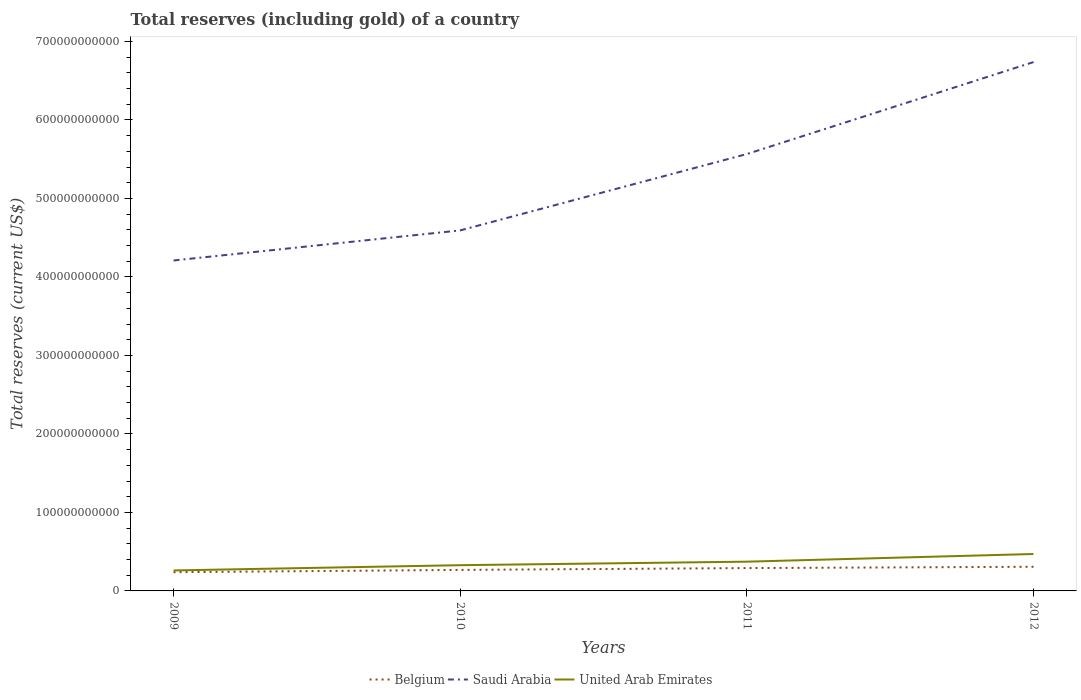Is the number of lines equal to the number of legend labels?
Offer a very short reply. Yes. Across all years, what is the maximum total reserves (including gold) in United Arab Emirates?
Provide a short and direct response. 2.61e+1. What is the total total reserves (including gold) in Belgium in the graph?
Provide a short and direct response. -3.99e+09. What is the difference between the highest and the second highest total reserves (including gold) in United Arab Emirates?
Ensure brevity in your answer.  2.09e+1. What is the difference between the highest and the lowest total reserves (including gold) in Saudi Arabia?
Your response must be concise. 2. Is the total reserves (including gold) in Saudi Arabia strictly greater than the total reserves (including gold) in United Arab Emirates over the years?
Offer a very short reply. No. How many years are there in the graph?
Ensure brevity in your answer.  4. What is the difference between two consecutive major ticks on the Y-axis?
Give a very brief answer. 1.00e+11. Are the values on the major ticks of Y-axis written in scientific E-notation?
Your answer should be compact. No. Where does the legend appear in the graph?
Provide a short and direct response. Bottom center. How many legend labels are there?
Offer a very short reply. 3. What is the title of the graph?
Provide a succinct answer. Total reserves (including gold) of a country. What is the label or title of the Y-axis?
Give a very brief answer. Total reserves (current US$). What is the Total reserves (current US$) of Belgium in 2009?
Provide a succinct answer. 2.39e+1. What is the Total reserves (current US$) in Saudi Arabia in 2009?
Ensure brevity in your answer.  4.21e+11. What is the Total reserves (current US$) in United Arab Emirates in 2009?
Your response must be concise. 2.61e+1. What is the Total reserves (current US$) of Belgium in 2010?
Keep it short and to the point. 2.68e+1. What is the Total reserves (current US$) in Saudi Arabia in 2010?
Offer a terse response. 4.59e+11. What is the Total reserves (current US$) of United Arab Emirates in 2010?
Provide a short and direct response. 3.28e+1. What is the Total reserves (current US$) in Belgium in 2011?
Provide a short and direct response. 2.91e+1. What is the Total reserves (current US$) in Saudi Arabia in 2011?
Provide a short and direct response. 5.57e+11. What is the Total reserves (current US$) of United Arab Emirates in 2011?
Your answer should be very brief. 3.73e+1. What is the Total reserves (current US$) in Belgium in 2012?
Provide a succinct answer. 3.08e+1. What is the Total reserves (current US$) in Saudi Arabia in 2012?
Your answer should be very brief. 6.74e+11. What is the Total reserves (current US$) in United Arab Emirates in 2012?
Your answer should be compact. 4.70e+1. Across all years, what is the maximum Total reserves (current US$) of Belgium?
Offer a very short reply. 3.08e+1. Across all years, what is the maximum Total reserves (current US$) of Saudi Arabia?
Make the answer very short. 6.74e+11. Across all years, what is the maximum Total reserves (current US$) in United Arab Emirates?
Your answer should be compact. 4.70e+1. Across all years, what is the minimum Total reserves (current US$) in Belgium?
Ensure brevity in your answer.  2.39e+1. Across all years, what is the minimum Total reserves (current US$) of Saudi Arabia?
Provide a succinct answer. 4.21e+11. Across all years, what is the minimum Total reserves (current US$) in United Arab Emirates?
Keep it short and to the point. 2.61e+1. What is the total Total reserves (current US$) of Belgium in the graph?
Make the answer very short. 1.11e+11. What is the total Total reserves (current US$) of Saudi Arabia in the graph?
Provide a short and direct response. 2.11e+12. What is the total Total reserves (current US$) in United Arab Emirates in the graph?
Your response must be concise. 1.43e+11. What is the difference between the Total reserves (current US$) in Belgium in 2009 and that in 2010?
Make the answer very short. -2.92e+09. What is the difference between the Total reserves (current US$) of Saudi Arabia in 2009 and that in 2010?
Offer a very short reply. -3.83e+1. What is the difference between the Total reserves (current US$) in United Arab Emirates in 2009 and that in 2010?
Offer a terse response. -6.68e+09. What is the difference between the Total reserves (current US$) in Belgium in 2009 and that in 2011?
Give a very brief answer. -5.25e+09. What is the difference between the Total reserves (current US$) of Saudi Arabia in 2009 and that in 2011?
Give a very brief answer. -1.36e+11. What is the difference between the Total reserves (current US$) in United Arab Emirates in 2009 and that in 2011?
Offer a terse response. -1.12e+1. What is the difference between the Total reserves (current US$) in Belgium in 2009 and that in 2012?
Give a very brief answer. -6.91e+09. What is the difference between the Total reserves (current US$) in Saudi Arabia in 2009 and that in 2012?
Your answer should be compact. -2.53e+11. What is the difference between the Total reserves (current US$) of United Arab Emirates in 2009 and that in 2012?
Provide a succinct answer. -2.09e+1. What is the difference between the Total reserves (current US$) of Belgium in 2010 and that in 2011?
Provide a short and direct response. -2.34e+09. What is the difference between the Total reserves (current US$) in Saudi Arabia in 2010 and that in 2011?
Your answer should be very brief. -9.73e+1. What is the difference between the Total reserves (current US$) in United Arab Emirates in 2010 and that in 2011?
Make the answer very short. -4.48e+09. What is the difference between the Total reserves (current US$) in Belgium in 2010 and that in 2012?
Offer a terse response. -3.99e+09. What is the difference between the Total reserves (current US$) in Saudi Arabia in 2010 and that in 2012?
Your response must be concise. -2.14e+11. What is the difference between the Total reserves (current US$) in United Arab Emirates in 2010 and that in 2012?
Make the answer very short. -1.42e+1. What is the difference between the Total reserves (current US$) in Belgium in 2011 and that in 2012?
Give a very brief answer. -1.65e+09. What is the difference between the Total reserves (current US$) of Saudi Arabia in 2011 and that in 2012?
Provide a short and direct response. -1.17e+11. What is the difference between the Total reserves (current US$) of United Arab Emirates in 2011 and that in 2012?
Ensure brevity in your answer.  -9.77e+09. What is the difference between the Total reserves (current US$) of Belgium in 2009 and the Total reserves (current US$) of Saudi Arabia in 2010?
Your answer should be very brief. -4.35e+11. What is the difference between the Total reserves (current US$) in Belgium in 2009 and the Total reserves (current US$) in United Arab Emirates in 2010?
Give a very brief answer. -8.92e+09. What is the difference between the Total reserves (current US$) in Saudi Arabia in 2009 and the Total reserves (current US$) in United Arab Emirates in 2010?
Offer a very short reply. 3.88e+11. What is the difference between the Total reserves (current US$) in Belgium in 2009 and the Total reserves (current US$) in Saudi Arabia in 2011?
Provide a succinct answer. -5.33e+11. What is the difference between the Total reserves (current US$) in Belgium in 2009 and the Total reserves (current US$) in United Arab Emirates in 2011?
Offer a terse response. -1.34e+1. What is the difference between the Total reserves (current US$) of Saudi Arabia in 2009 and the Total reserves (current US$) of United Arab Emirates in 2011?
Your answer should be very brief. 3.84e+11. What is the difference between the Total reserves (current US$) of Belgium in 2009 and the Total reserves (current US$) of Saudi Arabia in 2012?
Make the answer very short. -6.50e+11. What is the difference between the Total reserves (current US$) of Belgium in 2009 and the Total reserves (current US$) of United Arab Emirates in 2012?
Keep it short and to the point. -2.32e+1. What is the difference between the Total reserves (current US$) of Saudi Arabia in 2009 and the Total reserves (current US$) of United Arab Emirates in 2012?
Your answer should be very brief. 3.74e+11. What is the difference between the Total reserves (current US$) in Belgium in 2010 and the Total reserves (current US$) in Saudi Arabia in 2011?
Provide a succinct answer. -5.30e+11. What is the difference between the Total reserves (current US$) in Belgium in 2010 and the Total reserves (current US$) in United Arab Emirates in 2011?
Your answer should be compact. -1.05e+1. What is the difference between the Total reserves (current US$) of Saudi Arabia in 2010 and the Total reserves (current US$) of United Arab Emirates in 2011?
Make the answer very short. 4.22e+11. What is the difference between the Total reserves (current US$) in Belgium in 2010 and the Total reserves (current US$) in Saudi Arabia in 2012?
Offer a terse response. -6.47e+11. What is the difference between the Total reserves (current US$) in Belgium in 2010 and the Total reserves (current US$) in United Arab Emirates in 2012?
Provide a short and direct response. -2.03e+1. What is the difference between the Total reserves (current US$) in Saudi Arabia in 2010 and the Total reserves (current US$) in United Arab Emirates in 2012?
Your answer should be very brief. 4.12e+11. What is the difference between the Total reserves (current US$) of Belgium in 2011 and the Total reserves (current US$) of Saudi Arabia in 2012?
Your answer should be very brief. -6.45e+11. What is the difference between the Total reserves (current US$) of Belgium in 2011 and the Total reserves (current US$) of United Arab Emirates in 2012?
Provide a succinct answer. -1.79e+1. What is the difference between the Total reserves (current US$) in Saudi Arabia in 2011 and the Total reserves (current US$) in United Arab Emirates in 2012?
Provide a short and direct response. 5.10e+11. What is the average Total reserves (current US$) in Belgium per year?
Give a very brief answer. 2.76e+1. What is the average Total reserves (current US$) of Saudi Arabia per year?
Provide a short and direct response. 5.28e+11. What is the average Total reserves (current US$) in United Arab Emirates per year?
Ensure brevity in your answer.  3.58e+1. In the year 2009, what is the difference between the Total reserves (current US$) of Belgium and Total reserves (current US$) of Saudi Arabia?
Give a very brief answer. -3.97e+11. In the year 2009, what is the difference between the Total reserves (current US$) in Belgium and Total reserves (current US$) in United Arab Emirates?
Ensure brevity in your answer.  -2.24e+09. In the year 2009, what is the difference between the Total reserves (current US$) in Saudi Arabia and Total reserves (current US$) in United Arab Emirates?
Give a very brief answer. 3.95e+11. In the year 2010, what is the difference between the Total reserves (current US$) in Belgium and Total reserves (current US$) in Saudi Arabia?
Provide a succinct answer. -4.33e+11. In the year 2010, what is the difference between the Total reserves (current US$) of Belgium and Total reserves (current US$) of United Arab Emirates?
Your answer should be very brief. -6.01e+09. In the year 2010, what is the difference between the Total reserves (current US$) of Saudi Arabia and Total reserves (current US$) of United Arab Emirates?
Give a very brief answer. 4.27e+11. In the year 2011, what is the difference between the Total reserves (current US$) of Belgium and Total reserves (current US$) of Saudi Arabia?
Offer a very short reply. -5.27e+11. In the year 2011, what is the difference between the Total reserves (current US$) in Belgium and Total reserves (current US$) in United Arab Emirates?
Your response must be concise. -8.16e+09. In the year 2011, what is the difference between the Total reserves (current US$) of Saudi Arabia and Total reserves (current US$) of United Arab Emirates?
Your answer should be very brief. 5.19e+11. In the year 2012, what is the difference between the Total reserves (current US$) of Belgium and Total reserves (current US$) of Saudi Arabia?
Offer a very short reply. -6.43e+11. In the year 2012, what is the difference between the Total reserves (current US$) of Belgium and Total reserves (current US$) of United Arab Emirates?
Give a very brief answer. -1.63e+1. In the year 2012, what is the difference between the Total reserves (current US$) of Saudi Arabia and Total reserves (current US$) of United Arab Emirates?
Keep it short and to the point. 6.27e+11. What is the ratio of the Total reserves (current US$) in Belgium in 2009 to that in 2010?
Your response must be concise. 0.89. What is the ratio of the Total reserves (current US$) of Saudi Arabia in 2009 to that in 2010?
Provide a succinct answer. 0.92. What is the ratio of the Total reserves (current US$) in United Arab Emirates in 2009 to that in 2010?
Keep it short and to the point. 0.8. What is the ratio of the Total reserves (current US$) in Belgium in 2009 to that in 2011?
Provide a succinct answer. 0.82. What is the ratio of the Total reserves (current US$) in Saudi Arabia in 2009 to that in 2011?
Keep it short and to the point. 0.76. What is the ratio of the Total reserves (current US$) in United Arab Emirates in 2009 to that in 2011?
Your response must be concise. 0.7. What is the ratio of the Total reserves (current US$) of Belgium in 2009 to that in 2012?
Offer a terse response. 0.78. What is the ratio of the Total reserves (current US$) of Saudi Arabia in 2009 to that in 2012?
Provide a succinct answer. 0.62. What is the ratio of the Total reserves (current US$) in United Arab Emirates in 2009 to that in 2012?
Ensure brevity in your answer.  0.56. What is the ratio of the Total reserves (current US$) in Belgium in 2010 to that in 2011?
Provide a short and direct response. 0.92. What is the ratio of the Total reserves (current US$) of Saudi Arabia in 2010 to that in 2011?
Keep it short and to the point. 0.83. What is the ratio of the Total reserves (current US$) in United Arab Emirates in 2010 to that in 2011?
Offer a terse response. 0.88. What is the ratio of the Total reserves (current US$) in Belgium in 2010 to that in 2012?
Offer a terse response. 0.87. What is the ratio of the Total reserves (current US$) in Saudi Arabia in 2010 to that in 2012?
Ensure brevity in your answer.  0.68. What is the ratio of the Total reserves (current US$) in United Arab Emirates in 2010 to that in 2012?
Give a very brief answer. 0.7. What is the ratio of the Total reserves (current US$) of Belgium in 2011 to that in 2012?
Give a very brief answer. 0.95. What is the ratio of the Total reserves (current US$) of Saudi Arabia in 2011 to that in 2012?
Give a very brief answer. 0.83. What is the ratio of the Total reserves (current US$) of United Arab Emirates in 2011 to that in 2012?
Offer a very short reply. 0.79. What is the difference between the highest and the second highest Total reserves (current US$) of Belgium?
Ensure brevity in your answer.  1.65e+09. What is the difference between the highest and the second highest Total reserves (current US$) of Saudi Arabia?
Provide a short and direct response. 1.17e+11. What is the difference between the highest and the second highest Total reserves (current US$) in United Arab Emirates?
Make the answer very short. 9.77e+09. What is the difference between the highest and the lowest Total reserves (current US$) in Belgium?
Keep it short and to the point. 6.91e+09. What is the difference between the highest and the lowest Total reserves (current US$) of Saudi Arabia?
Ensure brevity in your answer.  2.53e+11. What is the difference between the highest and the lowest Total reserves (current US$) of United Arab Emirates?
Your response must be concise. 2.09e+1. 